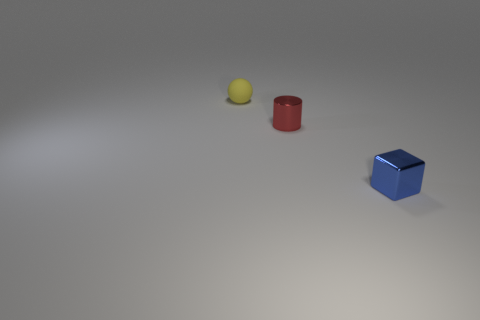Is the number of large red cubes the same as the number of small yellow spheres?
Make the answer very short. No. What number of tiny metallic things are left of the small blue metallic block and on the right side of the small red metal cylinder?
Make the answer very short. 0. What material is the small thing that is in front of the tiny shiny object that is left of the metallic object right of the small red cylinder?
Offer a terse response. Metal. How many tiny blue cylinders are the same material as the red thing?
Provide a succinct answer. 0. There is another metallic thing that is the same size as the red metallic object; what shape is it?
Keep it short and to the point. Cube. Are there any cylinders behind the red metallic object?
Keep it short and to the point. No. Are there any small purple things that have the same shape as the red object?
Your answer should be compact. No. Is the shape of the object that is left of the tiny red object the same as the metallic thing that is to the left of the small blue object?
Offer a very short reply. No. Are there any yellow things that have the same size as the blue cube?
Your answer should be very brief. Yes. Are there the same number of tiny red shiny things that are in front of the small yellow ball and tiny blue blocks that are right of the blue metallic cube?
Make the answer very short. No. 